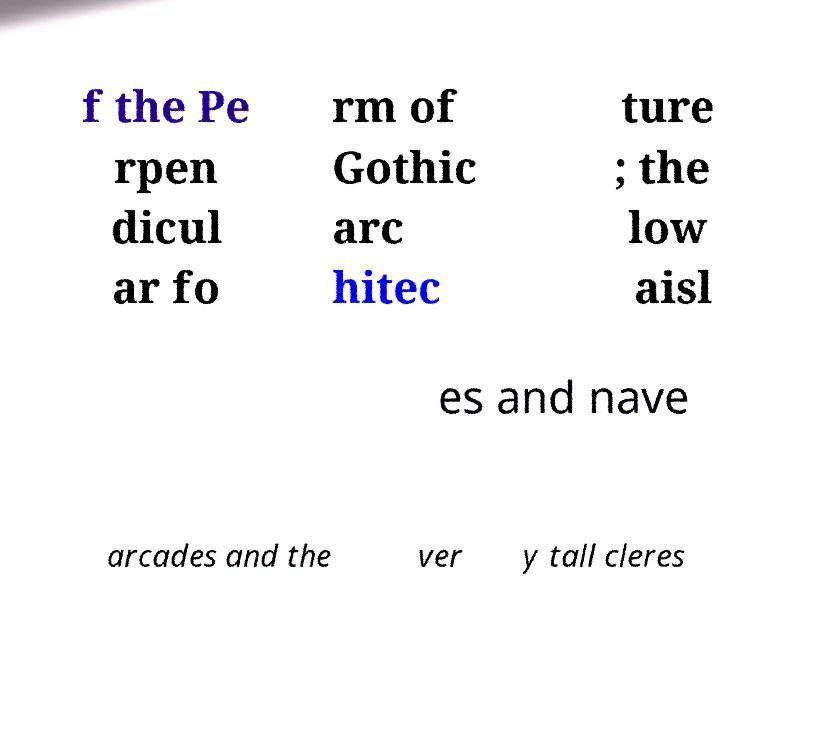For documentation purposes, I need the text within this image transcribed. Could you provide that? f the Pe rpen dicul ar fo rm of Gothic arc hitec ture ; the low aisl es and nave arcades and the ver y tall cleres 